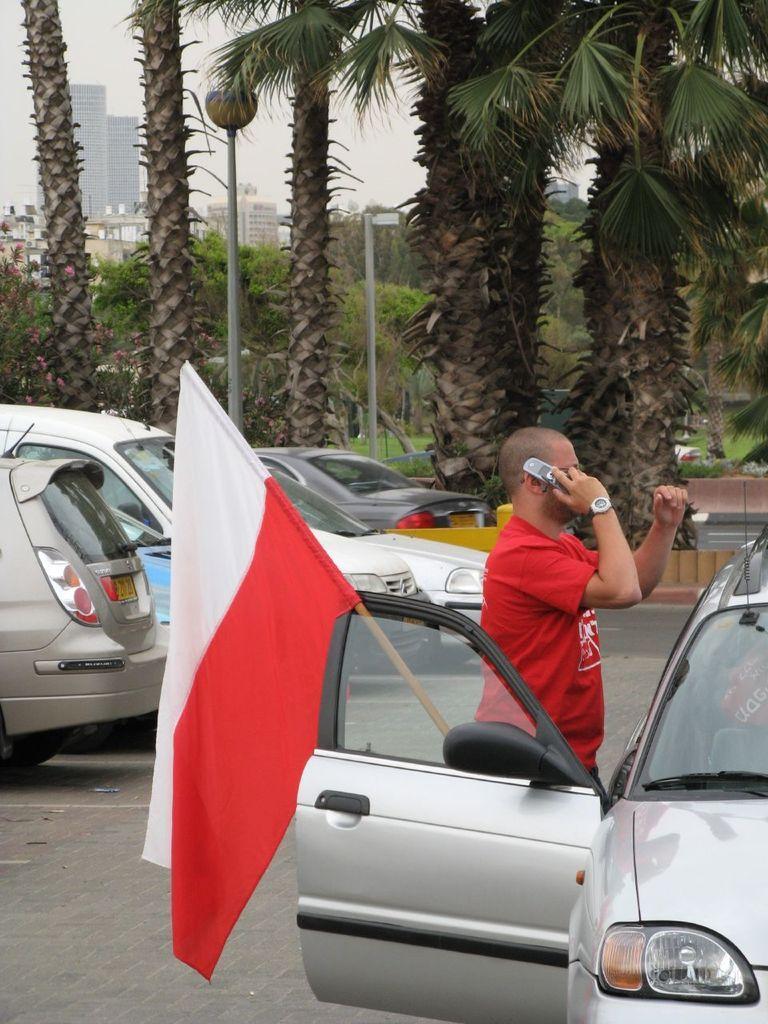Could you give a brief overview of what you see in this image? In this image we can see this person wearing red T-shirt is holding a mobile phone in his hands and standing near the car. Here we can see this car door is opened and a flag is kept here. In the background, we can see few more cars parked on the road, trees,light pole, buildings and sky. 